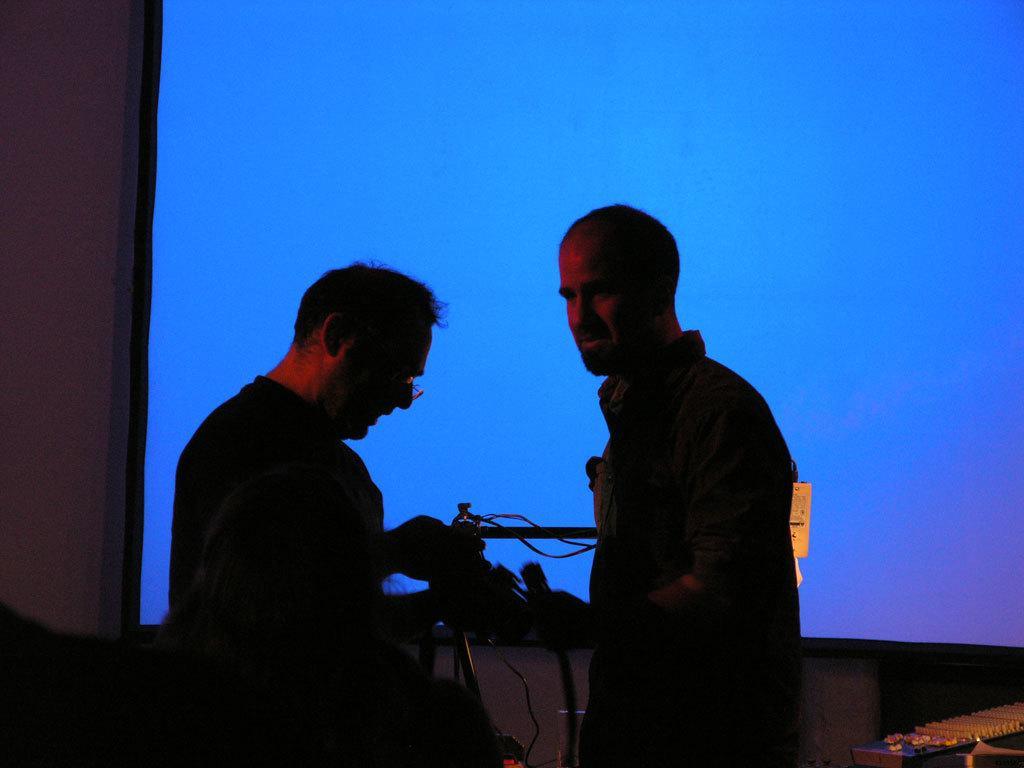How would you summarize this image in a sentence or two? In this image we can see three persons standing and holding some object in their hands and in the background of the image there is blue color screen. 